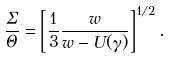Convert formula to latex. <formula><loc_0><loc_0><loc_500><loc_500>\frac { \Sigma } { \Theta } = \left [ \frac { 1 } { 3 } \frac { w } { w - U ( \gamma ) } \right ] ^ { 1 / 2 } .</formula> 